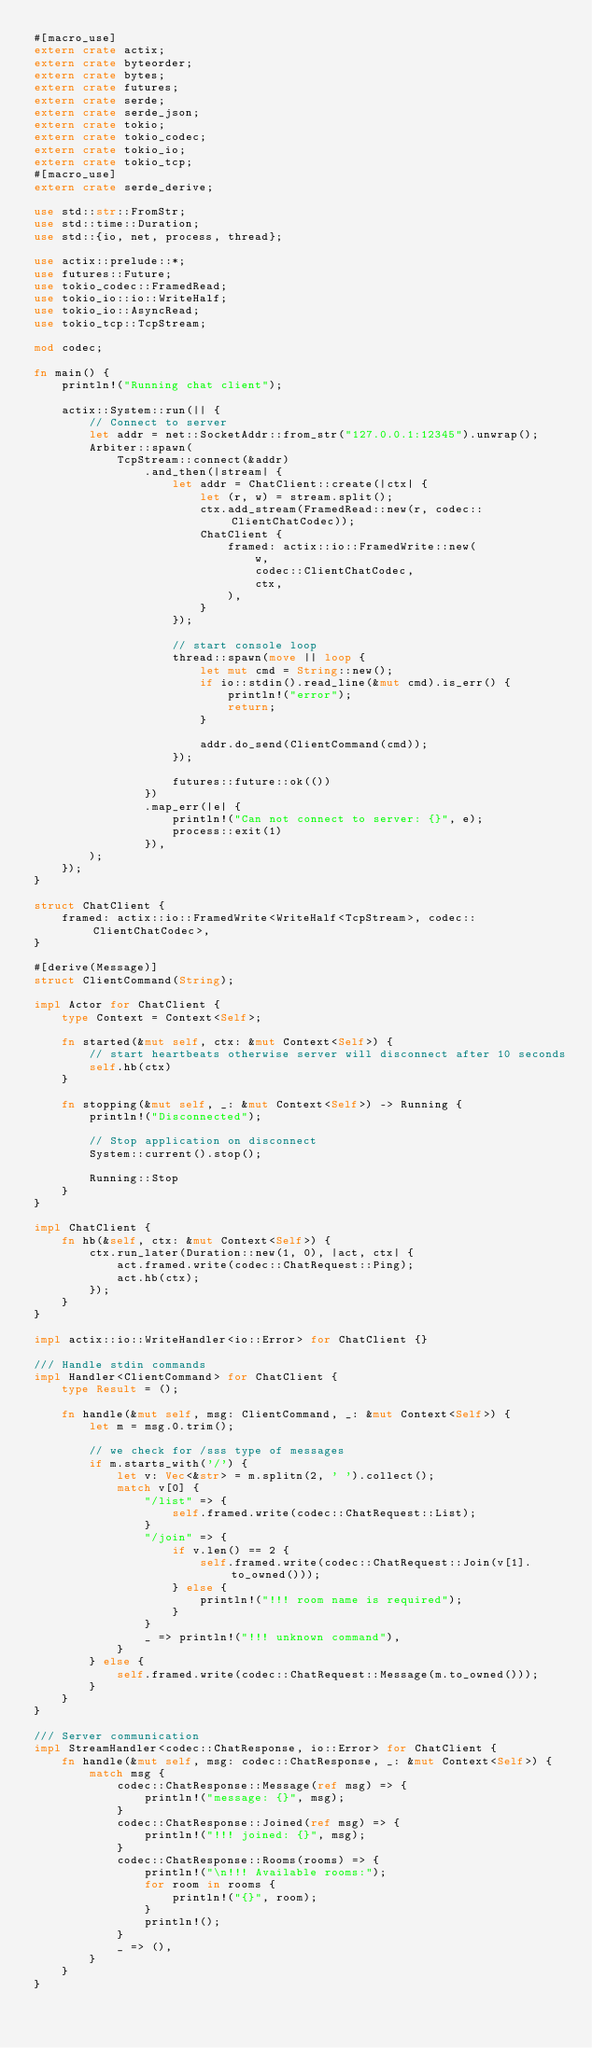Convert code to text. <code><loc_0><loc_0><loc_500><loc_500><_Rust_>#[macro_use]
extern crate actix;
extern crate byteorder;
extern crate bytes;
extern crate futures;
extern crate serde;
extern crate serde_json;
extern crate tokio;
extern crate tokio_codec;
extern crate tokio_io;
extern crate tokio_tcp;
#[macro_use]
extern crate serde_derive;

use std::str::FromStr;
use std::time::Duration;
use std::{io, net, process, thread};

use actix::prelude::*;
use futures::Future;
use tokio_codec::FramedRead;
use tokio_io::io::WriteHalf;
use tokio_io::AsyncRead;
use tokio_tcp::TcpStream;

mod codec;

fn main() {
    println!("Running chat client");

    actix::System::run(|| {
        // Connect to server
        let addr = net::SocketAddr::from_str("127.0.0.1:12345").unwrap();
        Arbiter::spawn(
            TcpStream::connect(&addr)
                .and_then(|stream| {
                    let addr = ChatClient::create(|ctx| {
                        let (r, w) = stream.split();
                        ctx.add_stream(FramedRead::new(r, codec::ClientChatCodec));
                        ChatClient {
                            framed: actix::io::FramedWrite::new(
                                w,
                                codec::ClientChatCodec,
                                ctx,
                            ),
                        }
                    });

                    // start console loop
                    thread::spawn(move || loop {
                        let mut cmd = String::new();
                        if io::stdin().read_line(&mut cmd).is_err() {
                            println!("error");
                            return;
                        }

                        addr.do_send(ClientCommand(cmd));
                    });

                    futures::future::ok(())
                })
                .map_err(|e| {
                    println!("Can not connect to server: {}", e);
                    process::exit(1)
                }),
        );
    });
}

struct ChatClient {
    framed: actix::io::FramedWrite<WriteHalf<TcpStream>, codec::ClientChatCodec>,
}

#[derive(Message)]
struct ClientCommand(String);

impl Actor for ChatClient {
    type Context = Context<Self>;

    fn started(&mut self, ctx: &mut Context<Self>) {
        // start heartbeats otherwise server will disconnect after 10 seconds
        self.hb(ctx)
    }

    fn stopping(&mut self, _: &mut Context<Self>) -> Running {
        println!("Disconnected");

        // Stop application on disconnect
        System::current().stop();

        Running::Stop
    }
}

impl ChatClient {
    fn hb(&self, ctx: &mut Context<Self>) {
        ctx.run_later(Duration::new(1, 0), |act, ctx| {
            act.framed.write(codec::ChatRequest::Ping);
            act.hb(ctx);
        });
    }
}

impl actix::io::WriteHandler<io::Error> for ChatClient {}

/// Handle stdin commands
impl Handler<ClientCommand> for ChatClient {
    type Result = ();

    fn handle(&mut self, msg: ClientCommand, _: &mut Context<Self>) {
        let m = msg.0.trim();

        // we check for /sss type of messages
        if m.starts_with('/') {
            let v: Vec<&str> = m.splitn(2, ' ').collect();
            match v[0] {
                "/list" => {
                    self.framed.write(codec::ChatRequest::List);
                }
                "/join" => {
                    if v.len() == 2 {
                        self.framed.write(codec::ChatRequest::Join(v[1].to_owned()));
                    } else {
                        println!("!!! room name is required");
                    }
                }
                _ => println!("!!! unknown command"),
            }
        } else {
            self.framed.write(codec::ChatRequest::Message(m.to_owned()));
        }
    }
}

/// Server communication
impl StreamHandler<codec::ChatResponse, io::Error> for ChatClient {
    fn handle(&mut self, msg: codec::ChatResponse, _: &mut Context<Self>) {
        match msg {
            codec::ChatResponse::Message(ref msg) => {
                println!("message: {}", msg);
            }
            codec::ChatResponse::Joined(ref msg) => {
                println!("!!! joined: {}", msg);
            }
            codec::ChatResponse::Rooms(rooms) => {
                println!("\n!!! Available rooms:");
                for room in rooms {
                    println!("{}", room);
                }
                println!();
            }
            _ => (),
        }
    }
}
</code> 